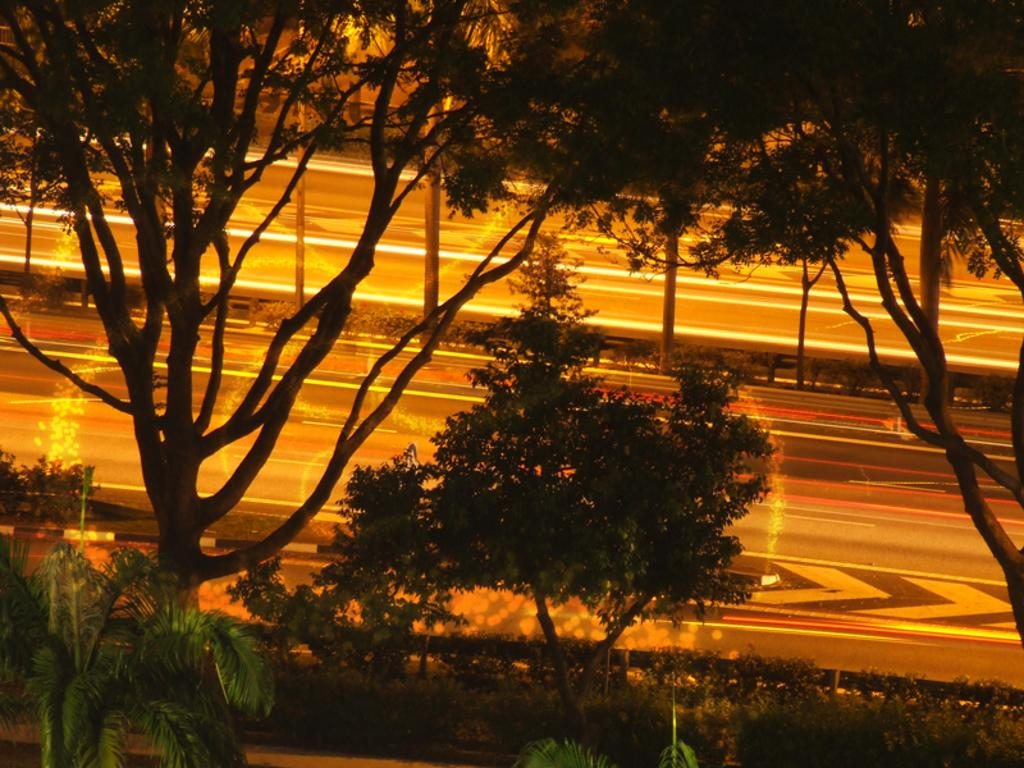What type of vegetation can be seen in the image? There are trees in the image. What is located behind the trees in the image? There is a road behind the trees. What structures can be seen in the image? There are poles in the image. Can you see a quill being used to write on the poles in the image? There is no quill or writing present on the poles in the image. Is there a stream visible in the image? There is no stream visible in the image; only trees, a road, and poles are present. 